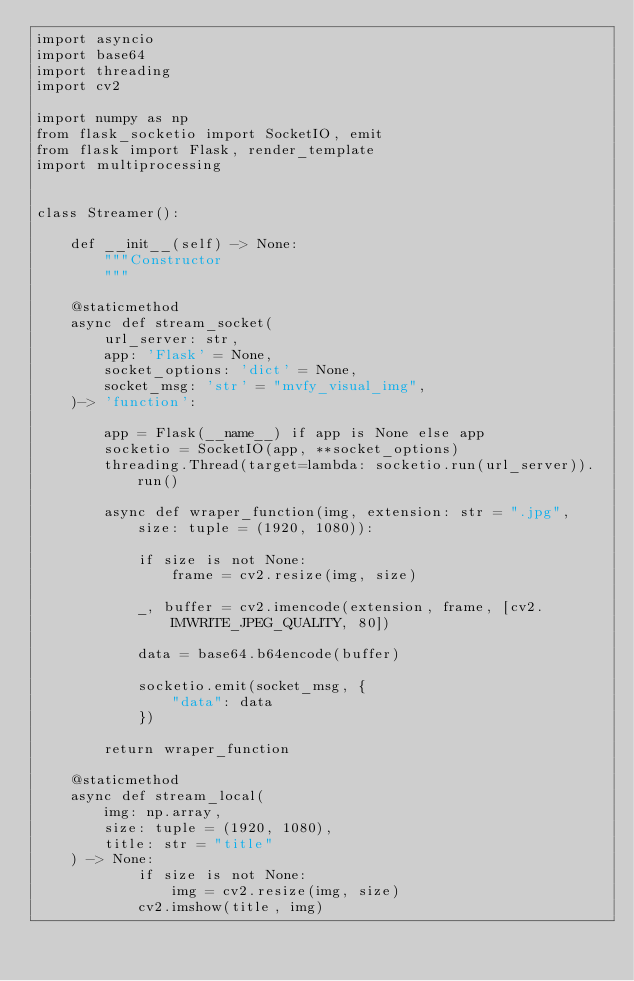<code> <loc_0><loc_0><loc_500><loc_500><_Python_>import asyncio
import base64
import threading
import cv2

import numpy as np
from flask_socketio import SocketIO, emit
from flask import Flask, render_template
import multiprocessing


class Streamer():

    def __init__(self) -> None:
        """Constructor
        """
        
    @staticmethod
    async def stream_socket(
        url_server: str, 
        app: 'Flask' = None,
        socket_options: 'dict' = None,
        socket_msg: 'str' = "mvfy_visual_img",
    )-> 'function':

        app = Flask(__name__) if app is None else app
        socketio = SocketIO(app, **socket_options) 
        threading.Thread(target=lambda: socketio.run(url_server)).run()

        async def wraper_function(img, extension: str = ".jpg", size: tuple = (1920, 1080)):
        
            if size is not None:
                frame = cv2.resize(img, size)

            _, buffer = cv2.imencode(extension, frame, [cv2.IMWRITE_JPEG_QUALITY, 80])
            
            data = base64.b64encode(buffer)

            socketio.emit(socket_msg, {
                "data": data
            })

        return wraper_function

    @staticmethod
    async def stream_local(
        img: np.array,
        size: tuple = (1920, 1080),
        title: str = "title"
    ) -> None:
            if size is not None:
                img = cv2.resize(img, size)
            cv2.imshow(title, img)</code> 